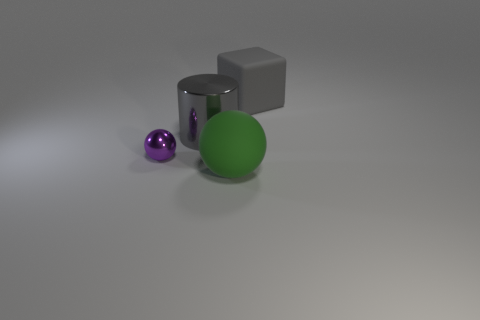There is a large matte object behind the big gray shiny object; is its color the same as the big shiny cylinder?
Give a very brief answer. Yes. Is there a large green object that has the same shape as the tiny metal object?
Keep it short and to the point. Yes. There is a gray object that is in front of the gray thing right of the big object in front of the purple metal object; what is its material?
Offer a very short reply. Metal. How many other things are there of the same size as the green matte sphere?
Keep it short and to the point. 2. The big block is what color?
Make the answer very short. Gray. How many shiny objects are either cylinders or small blue things?
Make the answer very short. 1. How big is the matte object that is to the right of the large thing that is in front of the gray cylinder right of the tiny ball?
Make the answer very short. Large. What size is the thing that is behind the purple ball and left of the big gray cube?
Your response must be concise. Large. There is a shiny cylinder that is on the left side of the rubber cube; is it the same color as the big matte thing that is to the left of the big gray matte cube?
Make the answer very short. No. There is a big block; how many big rubber things are in front of it?
Your response must be concise. 1. 